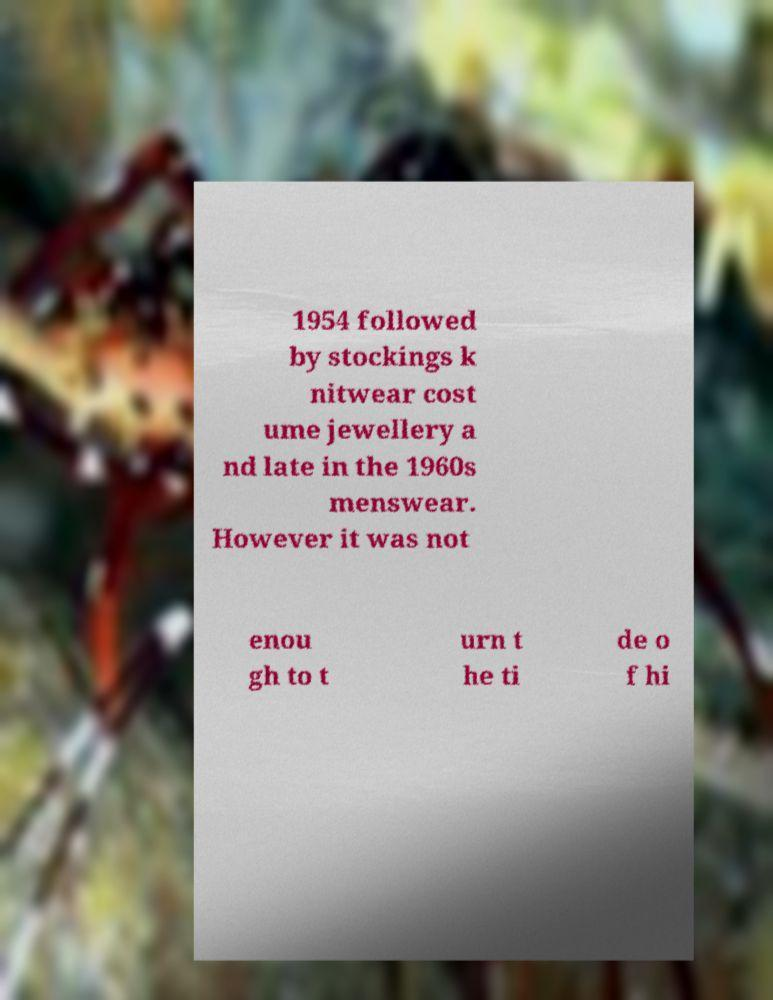Could you assist in decoding the text presented in this image and type it out clearly? 1954 followed by stockings k nitwear cost ume jewellery a nd late in the 1960s menswear. However it was not enou gh to t urn t he ti de o f hi 